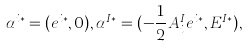Convert formula to latex. <formula><loc_0><loc_0><loc_500><loc_500>\alpha ^ { i * } = ( e ^ { i * } , 0 ) , \alpha ^ { I * } = ( - \frac { 1 } { 2 } A _ { i } ^ { I } e ^ { i * } , E ^ { I * } ) ,</formula> 